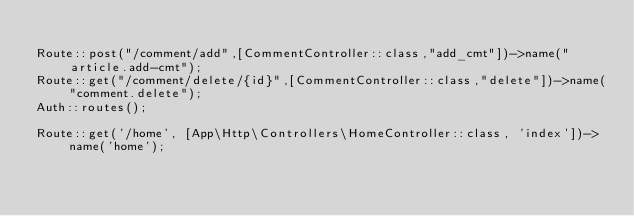Convert code to text. <code><loc_0><loc_0><loc_500><loc_500><_PHP_>
Route::post("/comment/add",[CommentController::class,"add_cmt"])->name("article.add-cmt");
Route::get("/comment/delete/{id}",[CommentController::class,"delete"])->name("comment.delete");
Auth::routes();

Route::get('/home', [App\Http\Controllers\HomeController::class, 'index'])->name('home');
</code> 